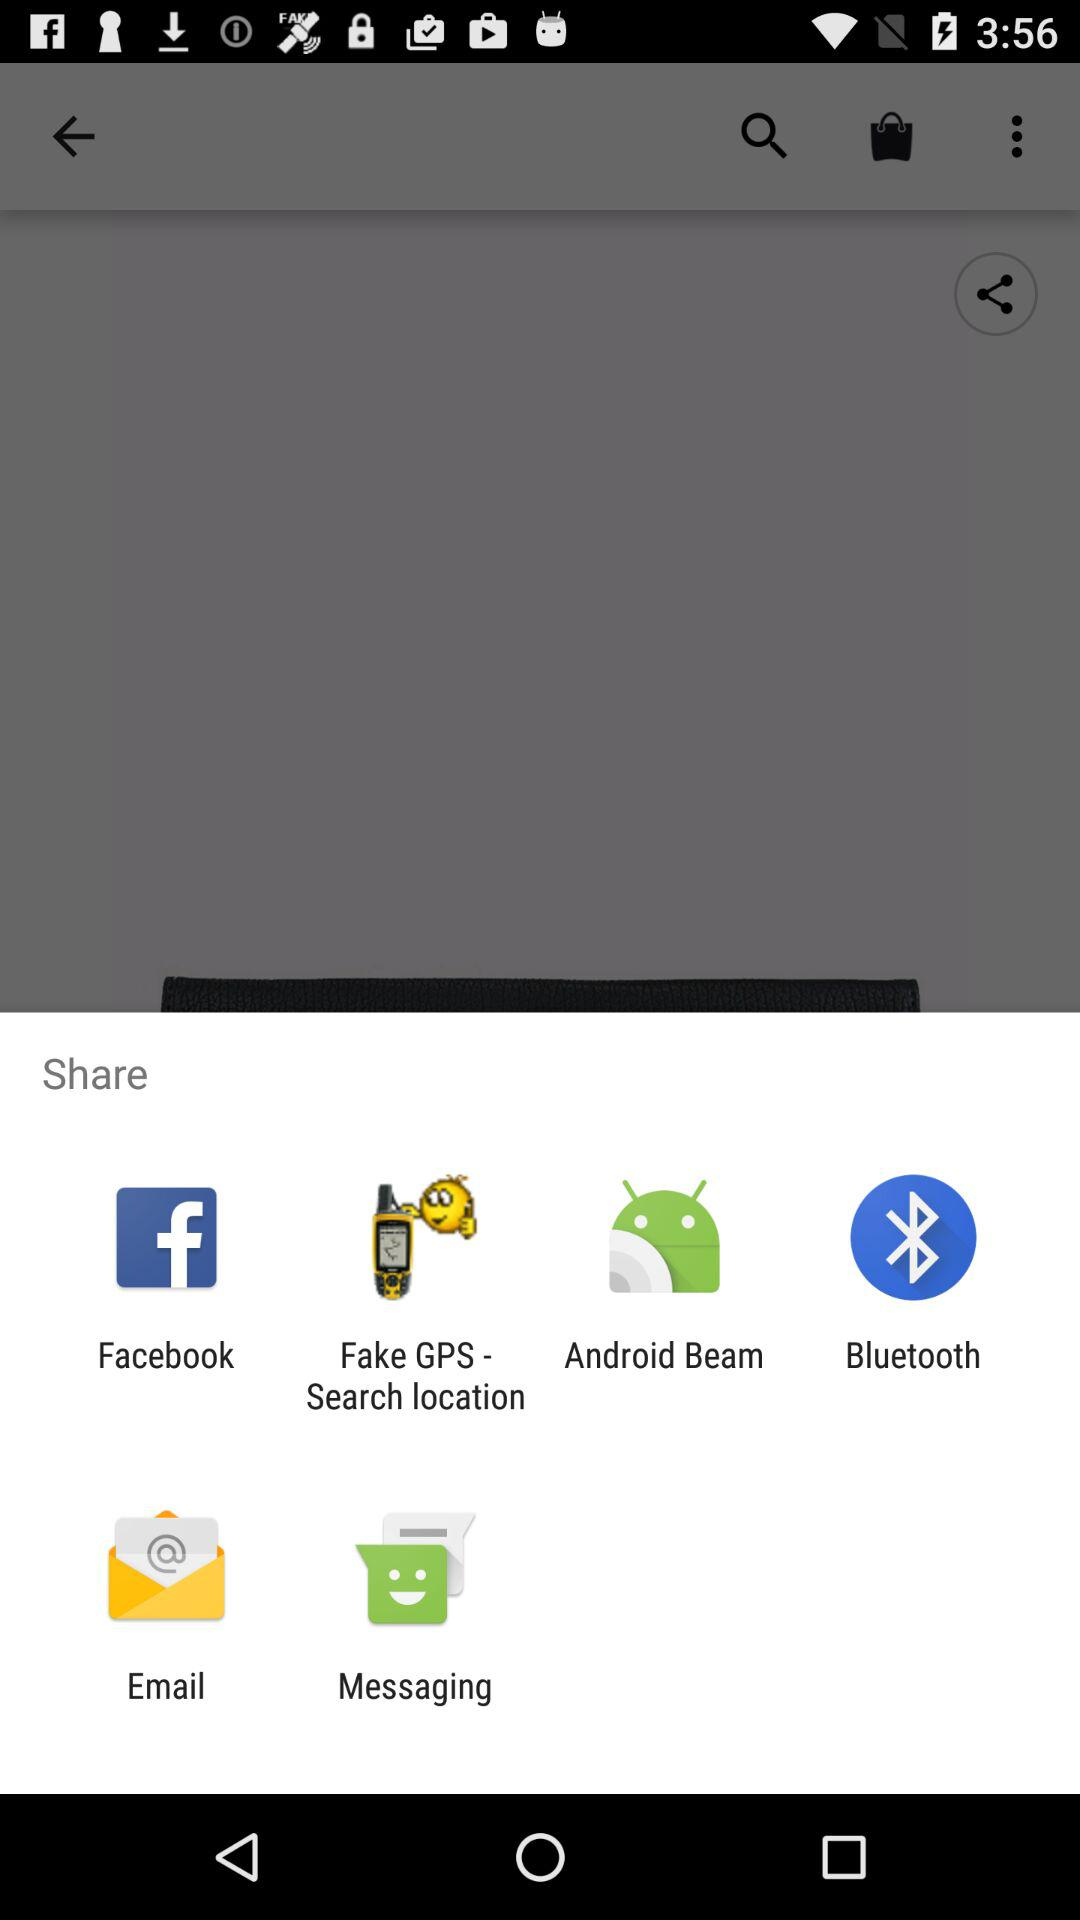What are the options for sharing? The options are "Facebook", "Fake GPS - Search location", "Android Beam", "Bluetooth", "Email" and "Messaging". 